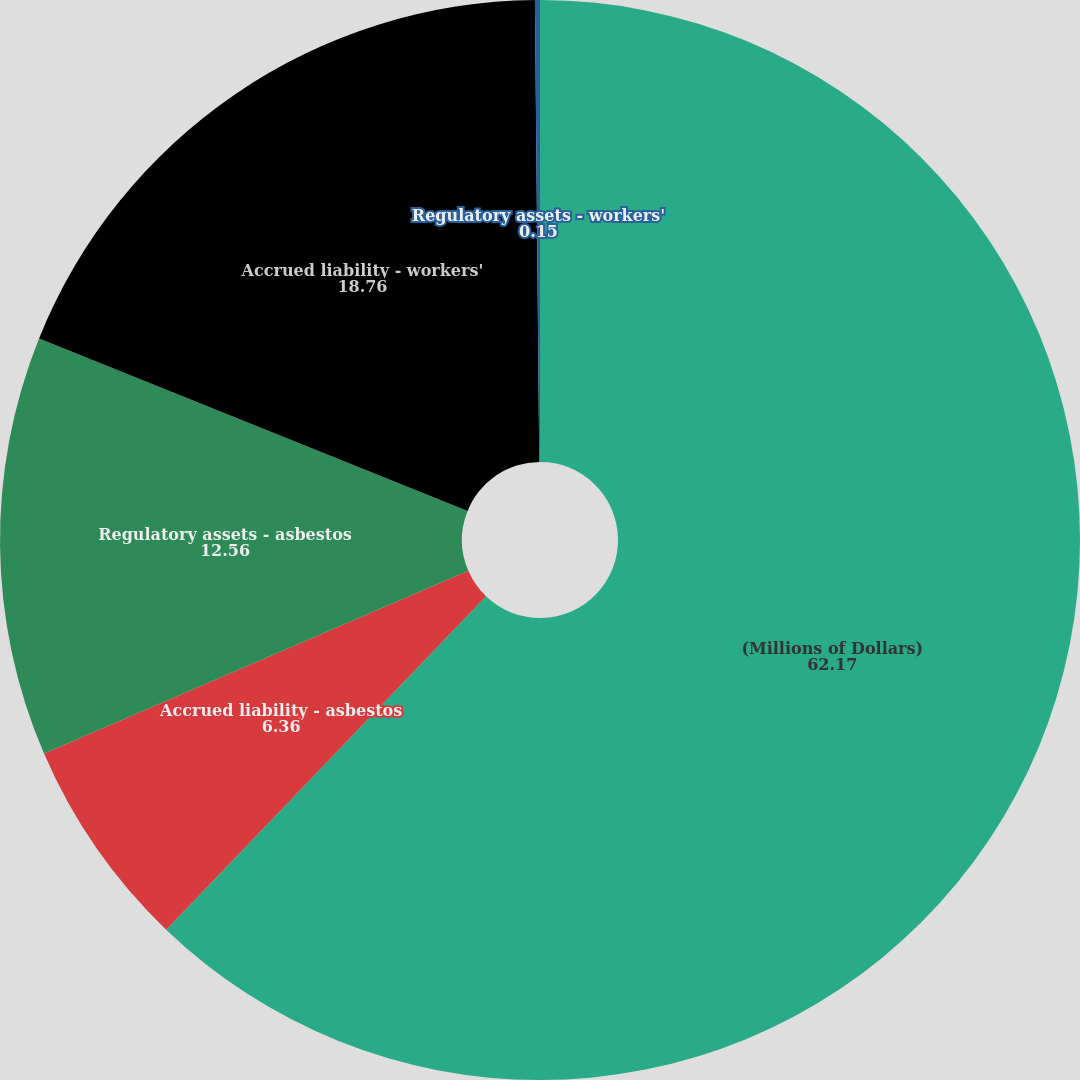<chart> <loc_0><loc_0><loc_500><loc_500><pie_chart><fcel>(Millions of Dollars)<fcel>Accrued liability - asbestos<fcel>Regulatory assets - asbestos<fcel>Accrued liability - workers'<fcel>Regulatory assets - workers'<nl><fcel>62.17%<fcel>6.36%<fcel>12.56%<fcel>18.76%<fcel>0.15%<nl></chart> 